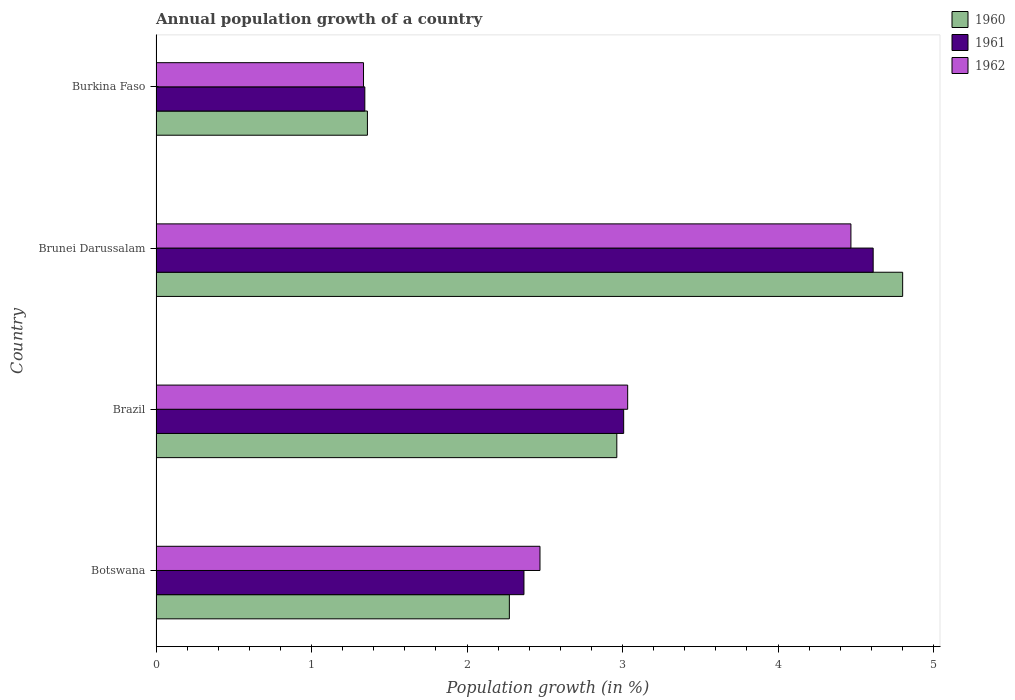How many groups of bars are there?
Provide a succinct answer. 4. Are the number of bars per tick equal to the number of legend labels?
Provide a short and direct response. Yes. Are the number of bars on each tick of the Y-axis equal?
Ensure brevity in your answer.  Yes. How many bars are there on the 4th tick from the top?
Make the answer very short. 3. What is the label of the 1st group of bars from the top?
Give a very brief answer. Burkina Faso. In how many cases, is the number of bars for a given country not equal to the number of legend labels?
Your answer should be compact. 0. What is the annual population growth in 1961 in Brazil?
Your answer should be compact. 3.01. Across all countries, what is the maximum annual population growth in 1960?
Offer a very short reply. 4.8. Across all countries, what is the minimum annual population growth in 1962?
Provide a short and direct response. 1.33. In which country was the annual population growth in 1960 maximum?
Keep it short and to the point. Brunei Darussalam. In which country was the annual population growth in 1960 minimum?
Your answer should be very brief. Burkina Faso. What is the total annual population growth in 1961 in the graph?
Provide a succinct answer. 11.33. What is the difference between the annual population growth in 1960 in Botswana and that in Brazil?
Your response must be concise. -0.69. What is the difference between the annual population growth in 1962 in Brazil and the annual population growth in 1961 in Botswana?
Provide a short and direct response. 0.67. What is the average annual population growth in 1962 per country?
Your answer should be compact. 2.83. What is the difference between the annual population growth in 1962 and annual population growth in 1961 in Burkina Faso?
Offer a very short reply. -0.01. What is the ratio of the annual population growth in 1960 in Brunei Darussalam to that in Burkina Faso?
Provide a succinct answer. 3.53. What is the difference between the highest and the second highest annual population growth in 1960?
Provide a succinct answer. 1.84. What is the difference between the highest and the lowest annual population growth in 1962?
Your answer should be very brief. 3.13. How many bars are there?
Your answer should be compact. 12. What is the difference between two consecutive major ticks on the X-axis?
Keep it short and to the point. 1. How many legend labels are there?
Your answer should be very brief. 3. How are the legend labels stacked?
Ensure brevity in your answer.  Vertical. What is the title of the graph?
Give a very brief answer. Annual population growth of a country. What is the label or title of the X-axis?
Keep it short and to the point. Population growth (in %). What is the Population growth (in %) in 1960 in Botswana?
Make the answer very short. 2.27. What is the Population growth (in %) of 1961 in Botswana?
Provide a succinct answer. 2.37. What is the Population growth (in %) of 1962 in Botswana?
Make the answer very short. 2.47. What is the Population growth (in %) of 1960 in Brazil?
Keep it short and to the point. 2.96. What is the Population growth (in %) in 1961 in Brazil?
Your response must be concise. 3.01. What is the Population growth (in %) in 1962 in Brazil?
Provide a short and direct response. 3.03. What is the Population growth (in %) of 1960 in Brunei Darussalam?
Offer a very short reply. 4.8. What is the Population growth (in %) in 1961 in Brunei Darussalam?
Keep it short and to the point. 4.61. What is the Population growth (in %) of 1962 in Brunei Darussalam?
Your response must be concise. 4.47. What is the Population growth (in %) of 1960 in Burkina Faso?
Give a very brief answer. 1.36. What is the Population growth (in %) of 1961 in Burkina Faso?
Your answer should be compact. 1.34. What is the Population growth (in %) in 1962 in Burkina Faso?
Your response must be concise. 1.33. Across all countries, what is the maximum Population growth (in %) of 1960?
Provide a short and direct response. 4.8. Across all countries, what is the maximum Population growth (in %) of 1961?
Provide a short and direct response. 4.61. Across all countries, what is the maximum Population growth (in %) of 1962?
Ensure brevity in your answer.  4.47. Across all countries, what is the minimum Population growth (in %) in 1960?
Make the answer very short. 1.36. Across all countries, what is the minimum Population growth (in %) in 1961?
Ensure brevity in your answer.  1.34. Across all countries, what is the minimum Population growth (in %) in 1962?
Your answer should be compact. 1.33. What is the total Population growth (in %) of 1960 in the graph?
Your answer should be very brief. 11.4. What is the total Population growth (in %) in 1961 in the graph?
Make the answer very short. 11.33. What is the total Population growth (in %) of 1962 in the graph?
Your answer should be very brief. 11.31. What is the difference between the Population growth (in %) in 1960 in Botswana and that in Brazil?
Offer a very short reply. -0.69. What is the difference between the Population growth (in %) in 1961 in Botswana and that in Brazil?
Keep it short and to the point. -0.64. What is the difference between the Population growth (in %) of 1962 in Botswana and that in Brazil?
Your response must be concise. -0.56. What is the difference between the Population growth (in %) of 1960 in Botswana and that in Brunei Darussalam?
Ensure brevity in your answer.  -2.53. What is the difference between the Population growth (in %) in 1961 in Botswana and that in Brunei Darussalam?
Make the answer very short. -2.25. What is the difference between the Population growth (in %) in 1962 in Botswana and that in Brunei Darussalam?
Make the answer very short. -2. What is the difference between the Population growth (in %) of 1960 in Botswana and that in Burkina Faso?
Offer a terse response. 0.91. What is the difference between the Population growth (in %) of 1961 in Botswana and that in Burkina Faso?
Keep it short and to the point. 1.02. What is the difference between the Population growth (in %) of 1962 in Botswana and that in Burkina Faso?
Provide a short and direct response. 1.13. What is the difference between the Population growth (in %) in 1960 in Brazil and that in Brunei Darussalam?
Your answer should be compact. -1.84. What is the difference between the Population growth (in %) of 1961 in Brazil and that in Brunei Darussalam?
Offer a very short reply. -1.6. What is the difference between the Population growth (in %) in 1962 in Brazil and that in Brunei Darussalam?
Provide a succinct answer. -1.44. What is the difference between the Population growth (in %) in 1960 in Brazil and that in Burkina Faso?
Make the answer very short. 1.6. What is the difference between the Population growth (in %) of 1961 in Brazil and that in Burkina Faso?
Your answer should be very brief. 1.66. What is the difference between the Population growth (in %) of 1962 in Brazil and that in Burkina Faso?
Your response must be concise. 1.7. What is the difference between the Population growth (in %) in 1960 in Brunei Darussalam and that in Burkina Faso?
Ensure brevity in your answer.  3.44. What is the difference between the Population growth (in %) in 1961 in Brunei Darussalam and that in Burkina Faso?
Give a very brief answer. 3.27. What is the difference between the Population growth (in %) of 1962 in Brunei Darussalam and that in Burkina Faso?
Your answer should be very brief. 3.13. What is the difference between the Population growth (in %) of 1960 in Botswana and the Population growth (in %) of 1961 in Brazil?
Keep it short and to the point. -0.74. What is the difference between the Population growth (in %) in 1960 in Botswana and the Population growth (in %) in 1962 in Brazil?
Your answer should be compact. -0.76. What is the difference between the Population growth (in %) in 1961 in Botswana and the Population growth (in %) in 1962 in Brazil?
Ensure brevity in your answer.  -0.67. What is the difference between the Population growth (in %) in 1960 in Botswana and the Population growth (in %) in 1961 in Brunei Darussalam?
Your answer should be very brief. -2.34. What is the difference between the Population growth (in %) of 1960 in Botswana and the Population growth (in %) of 1962 in Brunei Darussalam?
Your response must be concise. -2.2. What is the difference between the Population growth (in %) in 1961 in Botswana and the Population growth (in %) in 1962 in Brunei Darussalam?
Provide a succinct answer. -2.1. What is the difference between the Population growth (in %) of 1960 in Botswana and the Population growth (in %) of 1961 in Burkina Faso?
Make the answer very short. 0.93. What is the difference between the Population growth (in %) in 1960 in Botswana and the Population growth (in %) in 1962 in Burkina Faso?
Offer a terse response. 0.94. What is the difference between the Population growth (in %) in 1961 in Botswana and the Population growth (in %) in 1962 in Burkina Faso?
Offer a terse response. 1.03. What is the difference between the Population growth (in %) of 1960 in Brazil and the Population growth (in %) of 1961 in Brunei Darussalam?
Give a very brief answer. -1.65. What is the difference between the Population growth (in %) in 1960 in Brazil and the Population growth (in %) in 1962 in Brunei Darussalam?
Keep it short and to the point. -1.51. What is the difference between the Population growth (in %) in 1961 in Brazil and the Population growth (in %) in 1962 in Brunei Darussalam?
Give a very brief answer. -1.46. What is the difference between the Population growth (in %) in 1960 in Brazil and the Population growth (in %) in 1961 in Burkina Faso?
Your response must be concise. 1.62. What is the difference between the Population growth (in %) of 1960 in Brazil and the Population growth (in %) of 1962 in Burkina Faso?
Your answer should be very brief. 1.63. What is the difference between the Population growth (in %) of 1961 in Brazil and the Population growth (in %) of 1962 in Burkina Faso?
Your answer should be compact. 1.67. What is the difference between the Population growth (in %) in 1960 in Brunei Darussalam and the Population growth (in %) in 1961 in Burkina Faso?
Make the answer very short. 3.46. What is the difference between the Population growth (in %) in 1960 in Brunei Darussalam and the Population growth (in %) in 1962 in Burkina Faso?
Your answer should be compact. 3.47. What is the difference between the Population growth (in %) of 1961 in Brunei Darussalam and the Population growth (in %) of 1962 in Burkina Faso?
Provide a short and direct response. 3.28. What is the average Population growth (in %) in 1960 per country?
Your answer should be compact. 2.85. What is the average Population growth (in %) of 1961 per country?
Your answer should be compact. 2.83. What is the average Population growth (in %) of 1962 per country?
Your answer should be compact. 2.83. What is the difference between the Population growth (in %) in 1960 and Population growth (in %) in 1961 in Botswana?
Give a very brief answer. -0.09. What is the difference between the Population growth (in %) of 1960 and Population growth (in %) of 1962 in Botswana?
Keep it short and to the point. -0.2. What is the difference between the Population growth (in %) in 1961 and Population growth (in %) in 1962 in Botswana?
Offer a very short reply. -0.1. What is the difference between the Population growth (in %) in 1960 and Population growth (in %) in 1961 in Brazil?
Make the answer very short. -0.04. What is the difference between the Population growth (in %) of 1960 and Population growth (in %) of 1962 in Brazil?
Your answer should be very brief. -0.07. What is the difference between the Population growth (in %) in 1961 and Population growth (in %) in 1962 in Brazil?
Your answer should be very brief. -0.03. What is the difference between the Population growth (in %) in 1960 and Population growth (in %) in 1961 in Brunei Darussalam?
Your response must be concise. 0.19. What is the difference between the Population growth (in %) of 1960 and Population growth (in %) of 1962 in Brunei Darussalam?
Offer a terse response. 0.33. What is the difference between the Population growth (in %) in 1961 and Population growth (in %) in 1962 in Brunei Darussalam?
Your answer should be compact. 0.14. What is the difference between the Population growth (in %) in 1960 and Population growth (in %) in 1961 in Burkina Faso?
Your answer should be compact. 0.02. What is the difference between the Population growth (in %) in 1960 and Population growth (in %) in 1962 in Burkina Faso?
Offer a very short reply. 0.03. What is the difference between the Population growth (in %) of 1961 and Population growth (in %) of 1962 in Burkina Faso?
Keep it short and to the point. 0.01. What is the ratio of the Population growth (in %) of 1960 in Botswana to that in Brazil?
Offer a terse response. 0.77. What is the ratio of the Population growth (in %) in 1961 in Botswana to that in Brazil?
Provide a succinct answer. 0.79. What is the ratio of the Population growth (in %) of 1962 in Botswana to that in Brazil?
Ensure brevity in your answer.  0.81. What is the ratio of the Population growth (in %) in 1960 in Botswana to that in Brunei Darussalam?
Make the answer very short. 0.47. What is the ratio of the Population growth (in %) in 1961 in Botswana to that in Brunei Darussalam?
Your response must be concise. 0.51. What is the ratio of the Population growth (in %) in 1962 in Botswana to that in Brunei Darussalam?
Offer a very short reply. 0.55. What is the ratio of the Population growth (in %) in 1960 in Botswana to that in Burkina Faso?
Provide a succinct answer. 1.67. What is the ratio of the Population growth (in %) in 1961 in Botswana to that in Burkina Faso?
Make the answer very short. 1.76. What is the ratio of the Population growth (in %) of 1962 in Botswana to that in Burkina Faso?
Keep it short and to the point. 1.85. What is the ratio of the Population growth (in %) in 1960 in Brazil to that in Brunei Darussalam?
Your response must be concise. 0.62. What is the ratio of the Population growth (in %) of 1961 in Brazil to that in Brunei Darussalam?
Provide a short and direct response. 0.65. What is the ratio of the Population growth (in %) in 1962 in Brazil to that in Brunei Darussalam?
Your response must be concise. 0.68. What is the ratio of the Population growth (in %) of 1960 in Brazil to that in Burkina Faso?
Your answer should be compact. 2.18. What is the ratio of the Population growth (in %) in 1961 in Brazil to that in Burkina Faso?
Offer a very short reply. 2.24. What is the ratio of the Population growth (in %) in 1962 in Brazil to that in Burkina Faso?
Give a very brief answer. 2.27. What is the ratio of the Population growth (in %) of 1960 in Brunei Darussalam to that in Burkina Faso?
Your answer should be very brief. 3.53. What is the ratio of the Population growth (in %) in 1961 in Brunei Darussalam to that in Burkina Faso?
Give a very brief answer. 3.43. What is the ratio of the Population growth (in %) in 1962 in Brunei Darussalam to that in Burkina Faso?
Give a very brief answer. 3.35. What is the difference between the highest and the second highest Population growth (in %) in 1960?
Keep it short and to the point. 1.84. What is the difference between the highest and the second highest Population growth (in %) in 1961?
Offer a terse response. 1.6. What is the difference between the highest and the second highest Population growth (in %) of 1962?
Ensure brevity in your answer.  1.44. What is the difference between the highest and the lowest Population growth (in %) of 1960?
Provide a succinct answer. 3.44. What is the difference between the highest and the lowest Population growth (in %) of 1961?
Make the answer very short. 3.27. What is the difference between the highest and the lowest Population growth (in %) in 1962?
Provide a short and direct response. 3.13. 